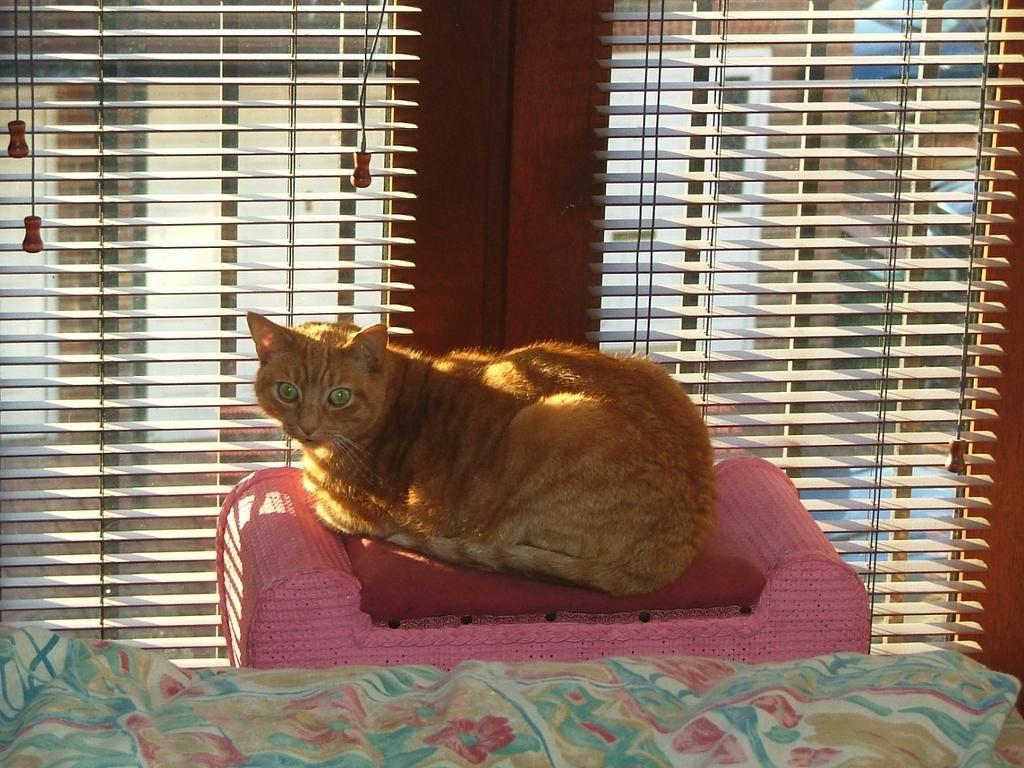How would you summarize this image in a sentence or two? In the center of the image we can see a cat sitting on the couch. At the bottom there is a cloth. In the background there are blinds. 